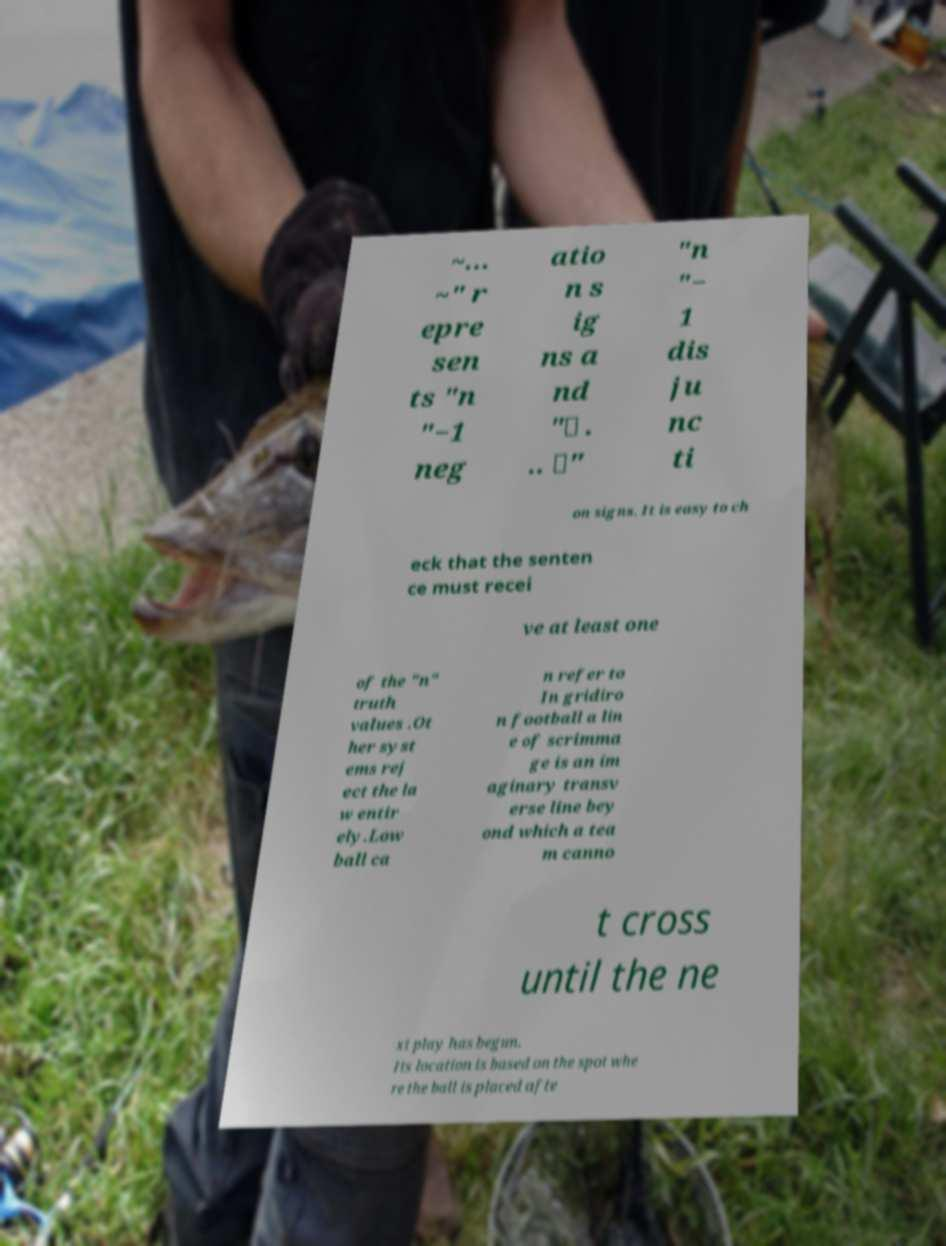Please read and relay the text visible in this image. What does it say? ~... ~" r epre sen ts "n "−1 neg atio n s ig ns a nd "∨ . .. ∨" "n "− 1 dis ju nc ti on signs. It is easy to ch eck that the senten ce must recei ve at least one of the "n" truth values .Ot her syst ems rej ect the la w entir ely.Low ball ca n refer to In gridiro n football a lin e of scrimma ge is an im aginary transv erse line bey ond which a tea m canno t cross until the ne xt play has begun. Its location is based on the spot whe re the ball is placed afte 